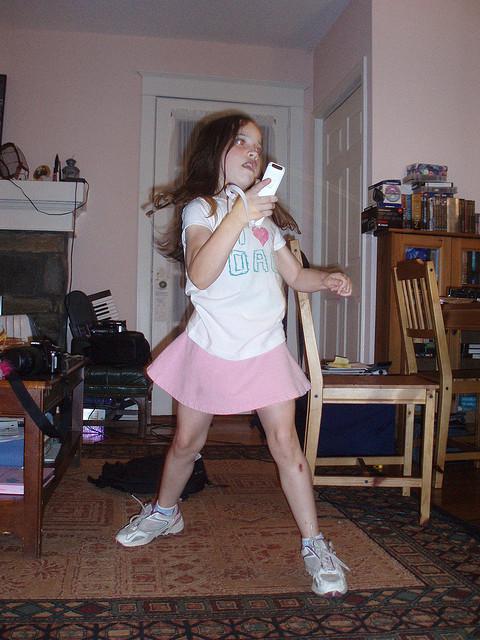What gaming console is the girl playing?
Keep it brief. Wii. What does the girls shirt say?
Quick response, please. I love dad. Is the girl wearing a dress?
Quick response, please. Yes. 